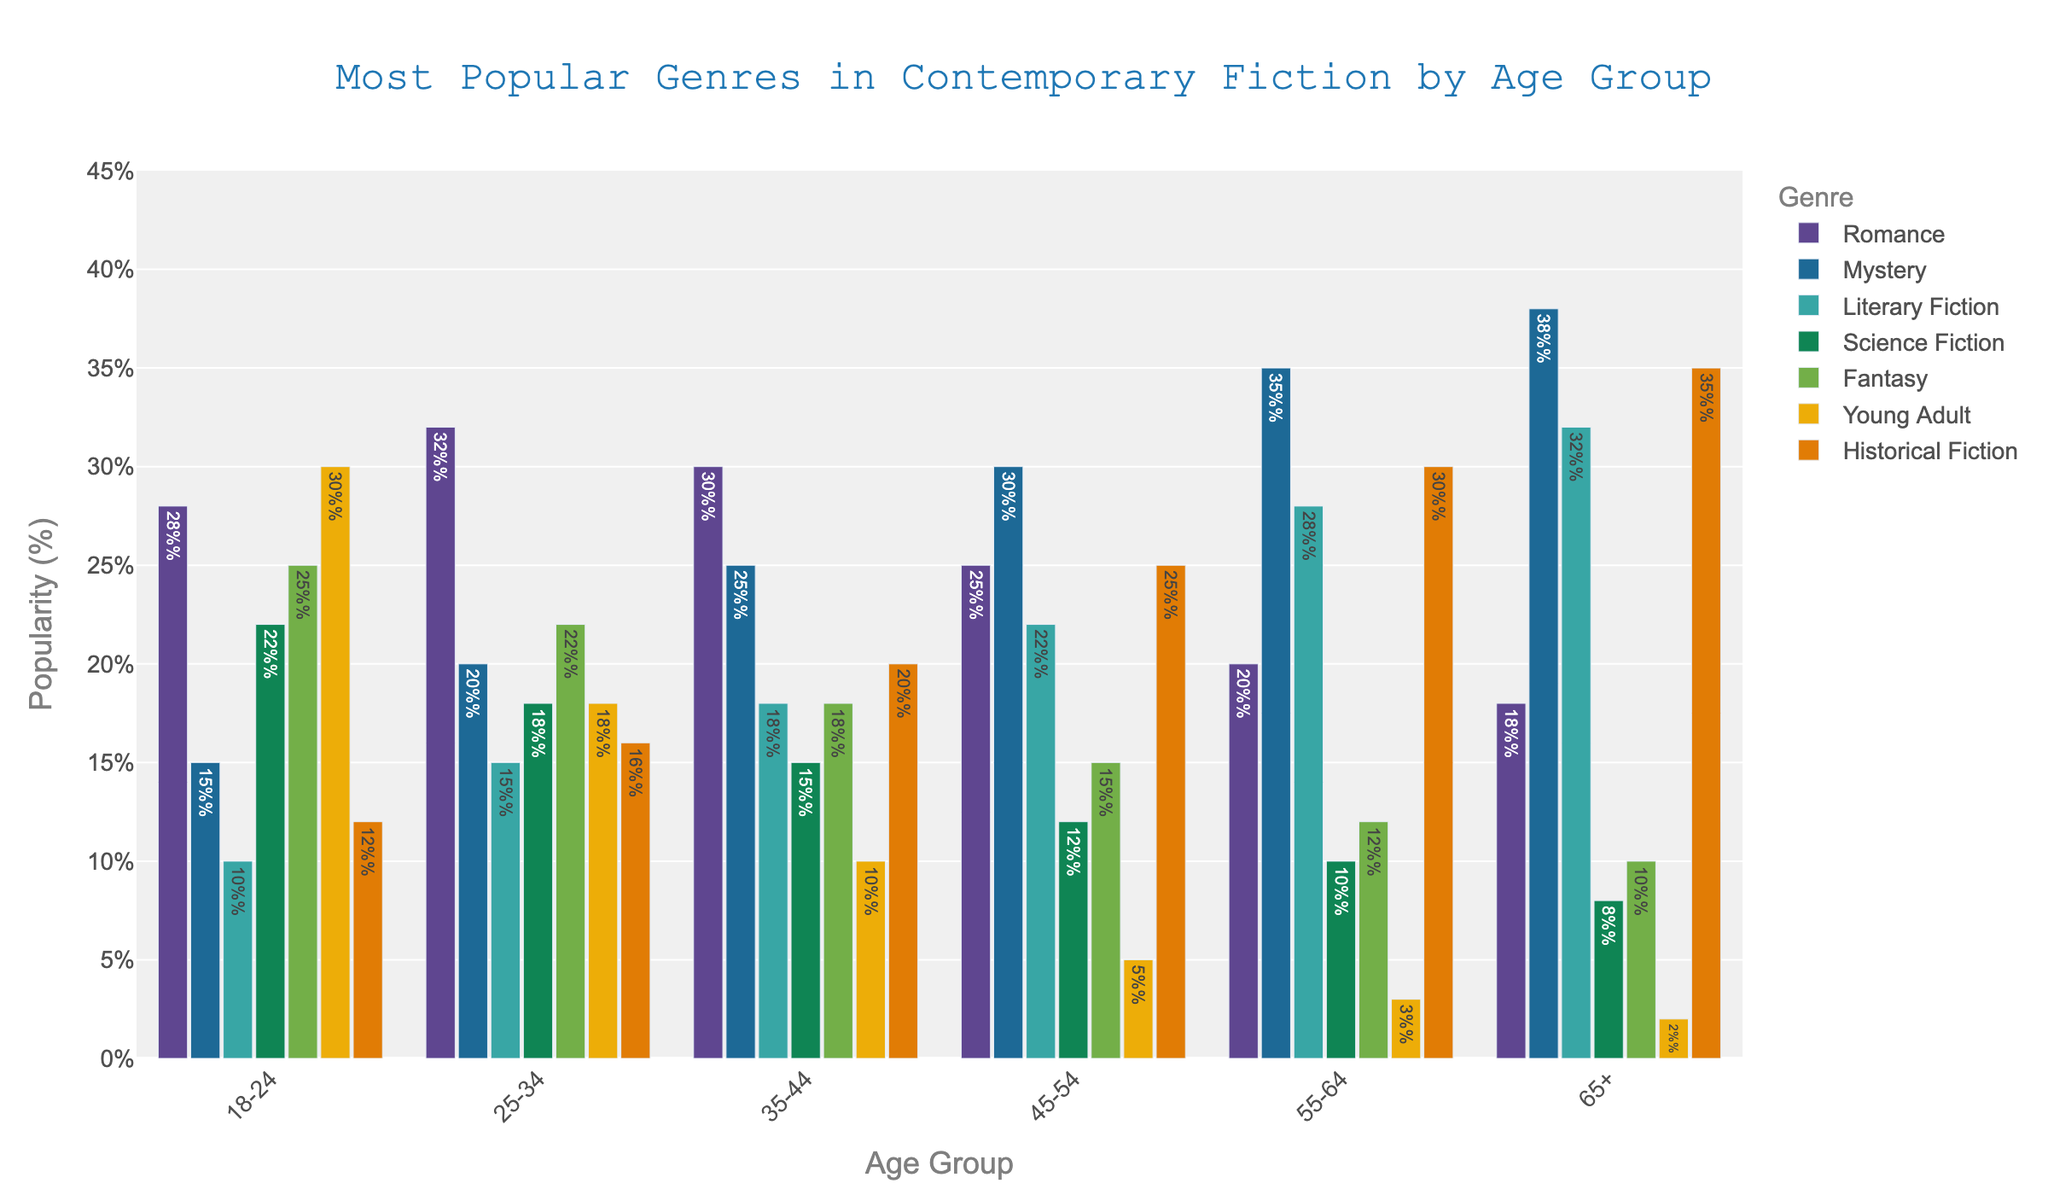what's the most popular genre for the 25-34 age group? Looking at the bar chart, the tallest bar within the 25-34 age group category corresponds to Romance. This indicates that Romance is the most popular genre for this age group.
Answer: Romance which age group favors Science Fiction the most? Observing the heights of the Science Fiction bars across different age groups, the 18-24 age group demonstrates the highest bar. This indicates that Science Fiction is most favored by the 18-24 age group.
Answer: 18-24 what's the difference in popularity between Romance and Fantasy for the 55-64 age group? For the 55-64 age group, the height of the Romance bar is 20%, and for Fantasy, it's 12%. Subtracting these values, 20% - 12% gives an 8% difference.
Answer: 8% compare the popularity of Mystery between the 18-24 and 65+ age groups Checking the heights of the Mystery bars, the height for the 18-24 age group is 15% and for the 65+ age group is 38%. This shows that Mystery is more popular in the 65+ group.
Answer: 65+ which genre is consistently more popular in older age groups (55-64, 65+) than younger age groups (18-24, 25-34)? By examining the bar heights, we can see that Historical Fiction remains consistently higher in the older age groups (30% and 35%) compared to the younger age groups (12% and 16%).
Answer: Historical Fiction what's the sum of the popularity percentages of Romance and Young Adult for the 18-24 age group? For the 18-24 age group, the Romance bar is 28% and the Young Adult bar is 30%. Adding these up, 28% + 30% equals 58%.
Answer: 58% how does the popularity of Literary Fiction compare between the 35-44 and 45-54 age groups? The heights of the Literary Fiction bars for the 35-44 and 45-54 age groups are 18% and 22%, respectively. This indicates that Literary Fiction is more popular in the 45-54 age group.
Answer: 35-44 which genre has the smallest overall variance in popularity across different age groups? Comparing the heights of the bars for each genre across different age groups, Science Fiction appears to have the smallest range, varying between 8% and 22%.
Answer: Science Fiction what's the average popularity of Historical Fiction across all age groups? The bars for Historical Fiction are 12%, 16%, 20%, 25%, 30%, and 35%. Adding these together, we get 138%. Dividing by the 6 age groups gives 138% / 6 = 23%.
Answer: 23% 